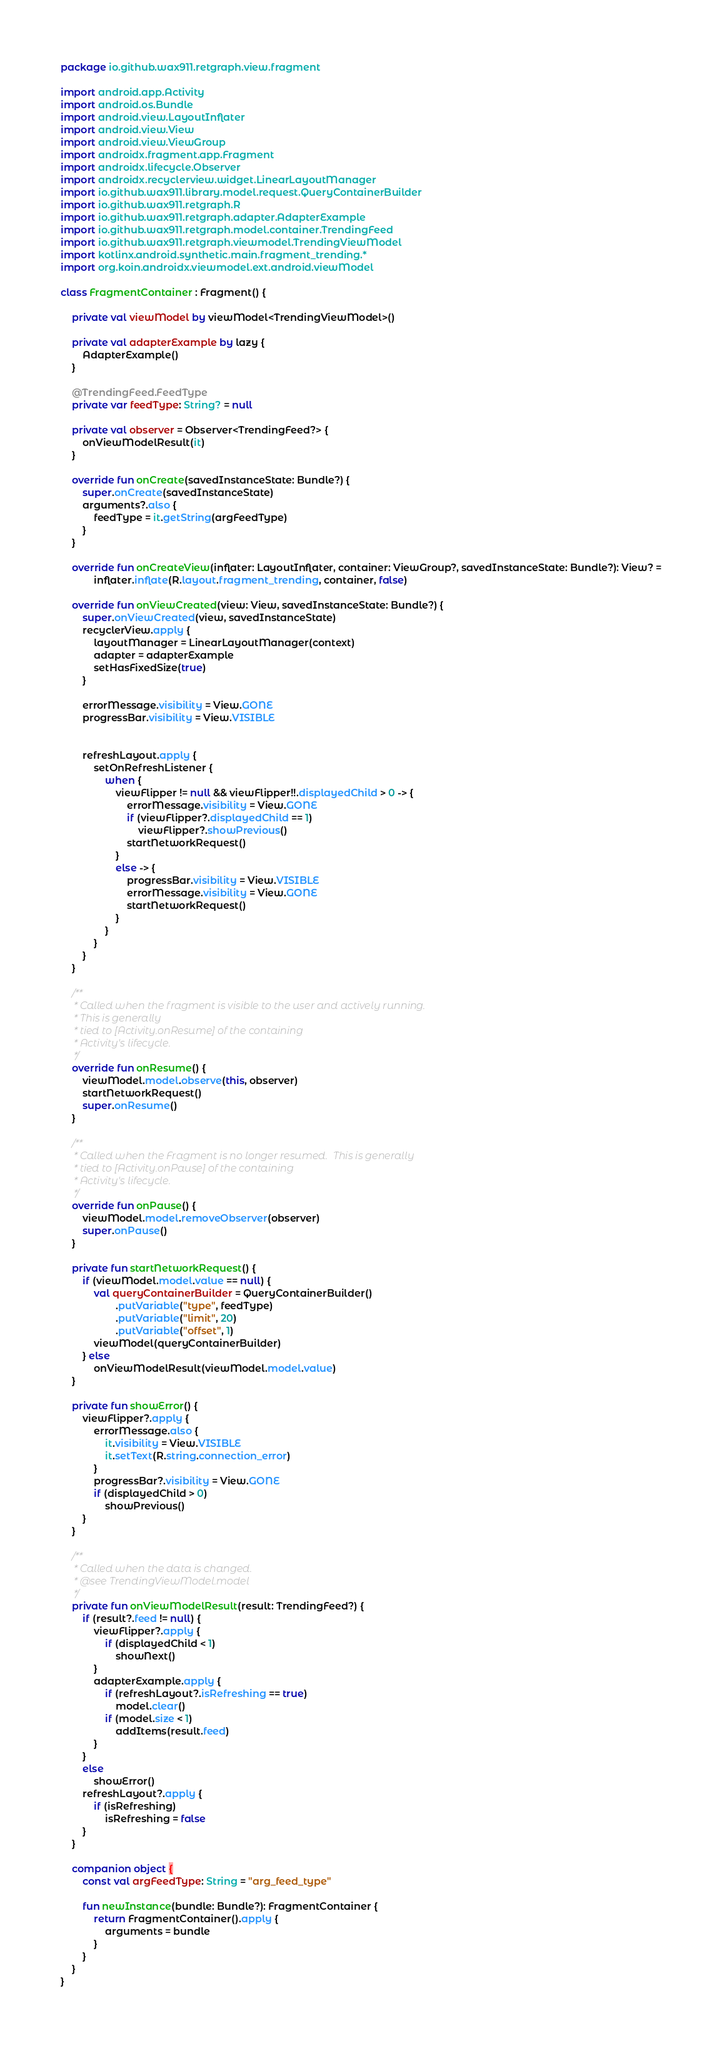Convert code to text. <code><loc_0><loc_0><loc_500><loc_500><_Kotlin_>package io.github.wax911.retgraph.view.fragment

import android.app.Activity
import android.os.Bundle
import android.view.LayoutInflater
import android.view.View
import android.view.ViewGroup
import androidx.fragment.app.Fragment
import androidx.lifecycle.Observer
import androidx.recyclerview.widget.LinearLayoutManager
import io.github.wax911.library.model.request.QueryContainerBuilder
import io.github.wax911.retgraph.R
import io.github.wax911.retgraph.adapter.AdapterExample
import io.github.wax911.retgraph.model.container.TrendingFeed
import io.github.wax911.retgraph.viewmodel.TrendingViewModel
import kotlinx.android.synthetic.main.fragment_trending.*
import org.koin.androidx.viewmodel.ext.android.viewModel

class FragmentContainer : Fragment() {

    private val viewModel by viewModel<TrendingViewModel>()

    private val adapterExample by lazy {
        AdapterExample()
    }

    @TrendingFeed.FeedType
    private var feedType: String? = null

    private val observer = Observer<TrendingFeed?> {
        onViewModelResult(it)
    }

    override fun onCreate(savedInstanceState: Bundle?) {
        super.onCreate(savedInstanceState)
        arguments?.also {
            feedType = it.getString(argFeedType)
        }
    }

    override fun onCreateView(inflater: LayoutInflater, container: ViewGroup?, savedInstanceState: Bundle?): View? =
            inflater.inflate(R.layout.fragment_trending, container, false)

    override fun onViewCreated(view: View, savedInstanceState: Bundle?) {
        super.onViewCreated(view, savedInstanceState)
        recyclerView.apply {
            layoutManager = LinearLayoutManager(context)
            adapter = adapterExample
            setHasFixedSize(true)
        }

        errorMessage.visibility = View.GONE
        progressBar.visibility = View.VISIBLE


        refreshLayout.apply {
            setOnRefreshListener {
                when {
                    viewFlipper != null && viewFlipper!!.displayedChild > 0 -> {
                        errorMessage.visibility = View.GONE
                        if (viewFlipper?.displayedChild == 1)
                            viewFlipper?.showPrevious()
                        startNetworkRequest()
                    }
                    else -> {
                        progressBar.visibility = View.VISIBLE
                        errorMessage.visibility = View.GONE
                        startNetworkRequest()
                    }
                }
            }
        }
    }

    /**
     * Called when the fragment is visible to the user and actively running.
     * This is generally
     * tied to [Activity.onResume] of the containing
     * Activity's lifecycle.
     */
    override fun onResume() {
        viewModel.model.observe(this, observer)
        startNetworkRequest()
        super.onResume()
    }

    /**
     * Called when the Fragment is no longer resumed.  This is generally
     * tied to [Activity.onPause] of the containing
     * Activity's lifecycle.
     */
    override fun onPause() {
        viewModel.model.removeObserver(observer)
        super.onPause()
    }

    private fun startNetworkRequest() {
        if (viewModel.model.value == null) {
            val queryContainerBuilder = QueryContainerBuilder()
                    .putVariable("type", feedType)
                    .putVariable("limit", 20)
                    .putVariable("offset", 1)
            viewModel(queryContainerBuilder)
        } else
            onViewModelResult(viewModel.model.value)
    }

    private fun showError() {
        viewFlipper?.apply {
            errorMessage.also {
                it.visibility = View.VISIBLE
                it.setText(R.string.connection_error)
            }
            progressBar?.visibility = View.GONE
            if (displayedChild > 0)
                showPrevious()
        }
    }

    /**
     * Called when the data is changed.
     * @see TrendingViewModel.model
     */
    private fun onViewModelResult(result: TrendingFeed?) {
        if (result?.feed != null) {
            viewFlipper?.apply {
                if (displayedChild < 1)
                    showNext()
            }
            adapterExample.apply {
                if (refreshLayout?.isRefreshing == true)
                    model.clear()
                if (model.size < 1)
                    addItems(result.feed)
            }
        }
        else
            showError()
        refreshLayout?.apply {
            if (isRefreshing)
                isRefreshing = false
        }
    }

    companion object {
        const val argFeedType: String = "arg_feed_type"

        fun newInstance(bundle: Bundle?): FragmentContainer {
            return FragmentContainer().apply {
                arguments = bundle
            }
        }
    }
}</code> 